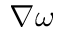<formula> <loc_0><loc_0><loc_500><loc_500>\nabla \omega</formula> 